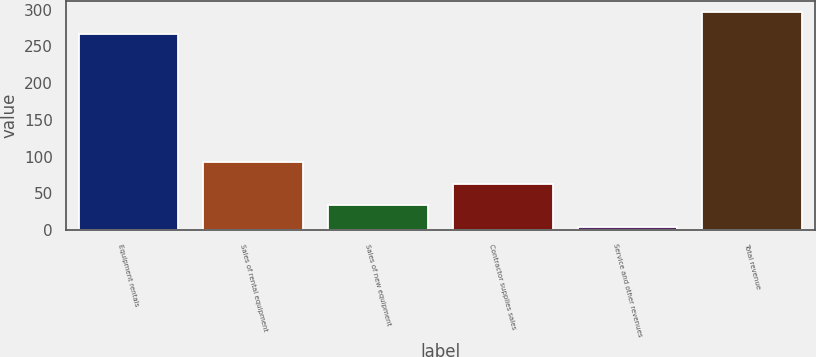Convert chart. <chart><loc_0><loc_0><loc_500><loc_500><bar_chart><fcel>Equipment rentals<fcel>Sales of rental equipment<fcel>Sales of new equipment<fcel>Contractor supplies sales<fcel>Service and other revenues<fcel>Total revenue<nl><fcel>267<fcel>91.9<fcel>33.3<fcel>62.6<fcel>4<fcel>297<nl></chart> 